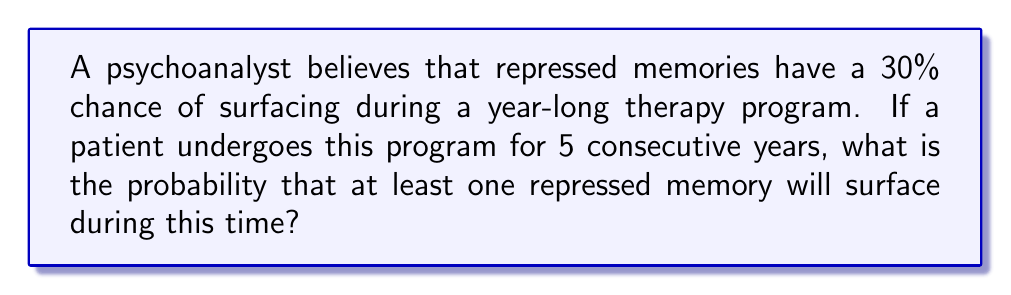Give your solution to this math problem. To solve this problem, we can use the concept of complementary events in probability theory.

Let's define the events:
$A$: At least one repressed memory surfaces in 5 years
$B$: No repressed memories surface in 5 years

We want to find $P(A)$, but it's easier to calculate $P(B)$ first.

Step 1: Calculate the probability of no memories surfacing in one year.
$P(\text{no memory in 1 year}) = 1 - 0.30 = 0.70$

Step 2: For no memories to surface in 5 years, this must happen every year independently. So we multiply the probabilities:

$P(B) = (0.70)^5 = 0.16807$

Step 3: Since $A$ and $B$ are complementary events, their probabilities sum to 1:

$P(A) + P(B) = 1$

$P(A) = 1 - P(B) = 1 - 0.16807 = 0.83193$

Therefore, the probability that at least one repressed memory will surface during the 5-year therapy program is approximately 0.83193 or 83.193%.
Answer: The probability is approximately 0.83193 or 83.193%. 